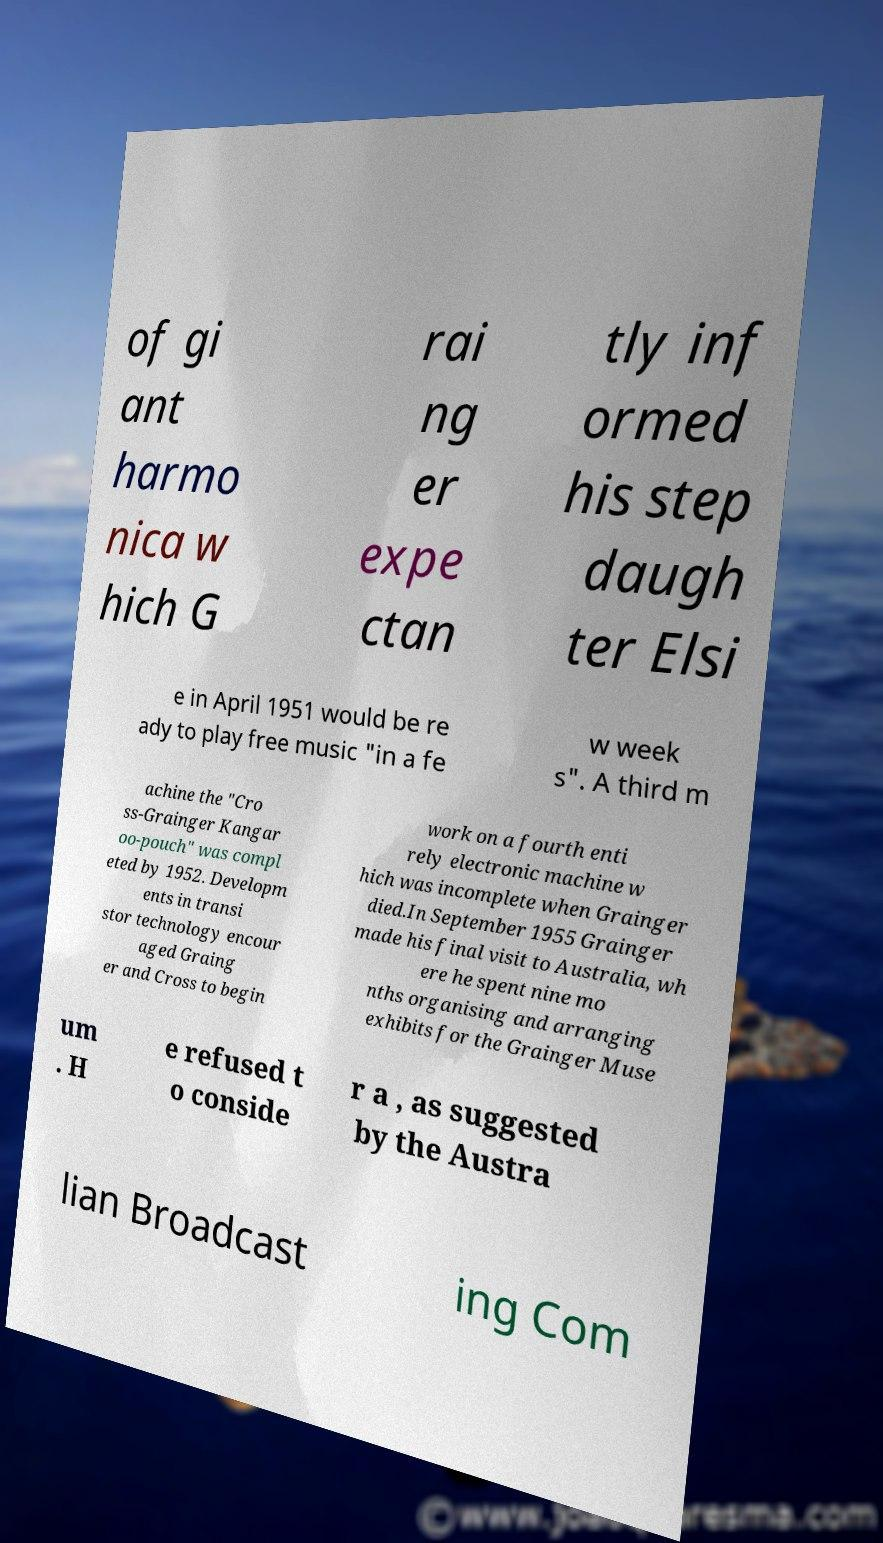Please read and relay the text visible in this image. What does it say? of gi ant harmo nica w hich G rai ng er expe ctan tly inf ormed his step daugh ter Elsi e in April 1951 would be re ady to play free music "in a fe w week s". A third m achine the "Cro ss-Grainger Kangar oo-pouch" was compl eted by 1952. Developm ents in transi stor technology encour aged Graing er and Cross to begin work on a fourth enti rely electronic machine w hich was incomplete when Grainger died.In September 1955 Grainger made his final visit to Australia, wh ere he spent nine mo nths organising and arranging exhibits for the Grainger Muse um . H e refused t o conside r a , as suggested by the Austra lian Broadcast ing Com 